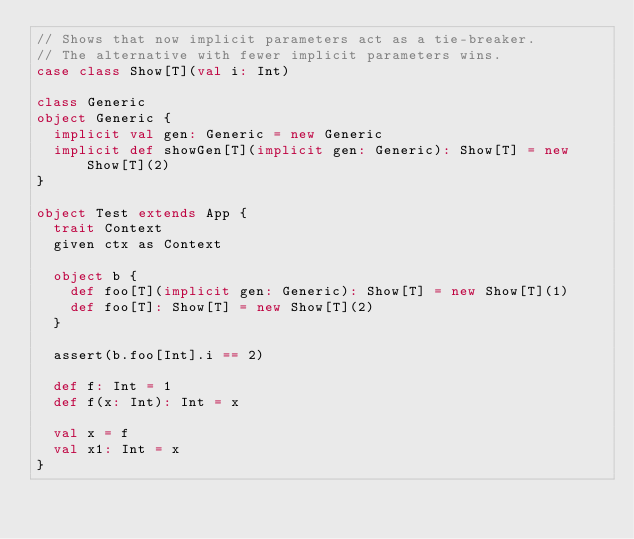Convert code to text. <code><loc_0><loc_0><loc_500><loc_500><_Scala_>// Shows that now implicit parameters act as a tie-breaker.
// The alternative with fewer implicit parameters wins.
case class Show[T](val i: Int)

class Generic
object Generic {
  implicit val gen: Generic = new Generic
  implicit def showGen[T](implicit gen: Generic): Show[T] = new Show[T](2)
}

object Test extends App {
  trait Context
  given ctx as Context

  object b {
    def foo[T](implicit gen: Generic): Show[T] = new Show[T](1)
    def foo[T]: Show[T] = new Show[T](2)
  }

  assert(b.foo[Int].i == 2)

  def f: Int = 1
  def f(x: Int): Int = x

  val x = f
  val x1: Int = x
}</code> 